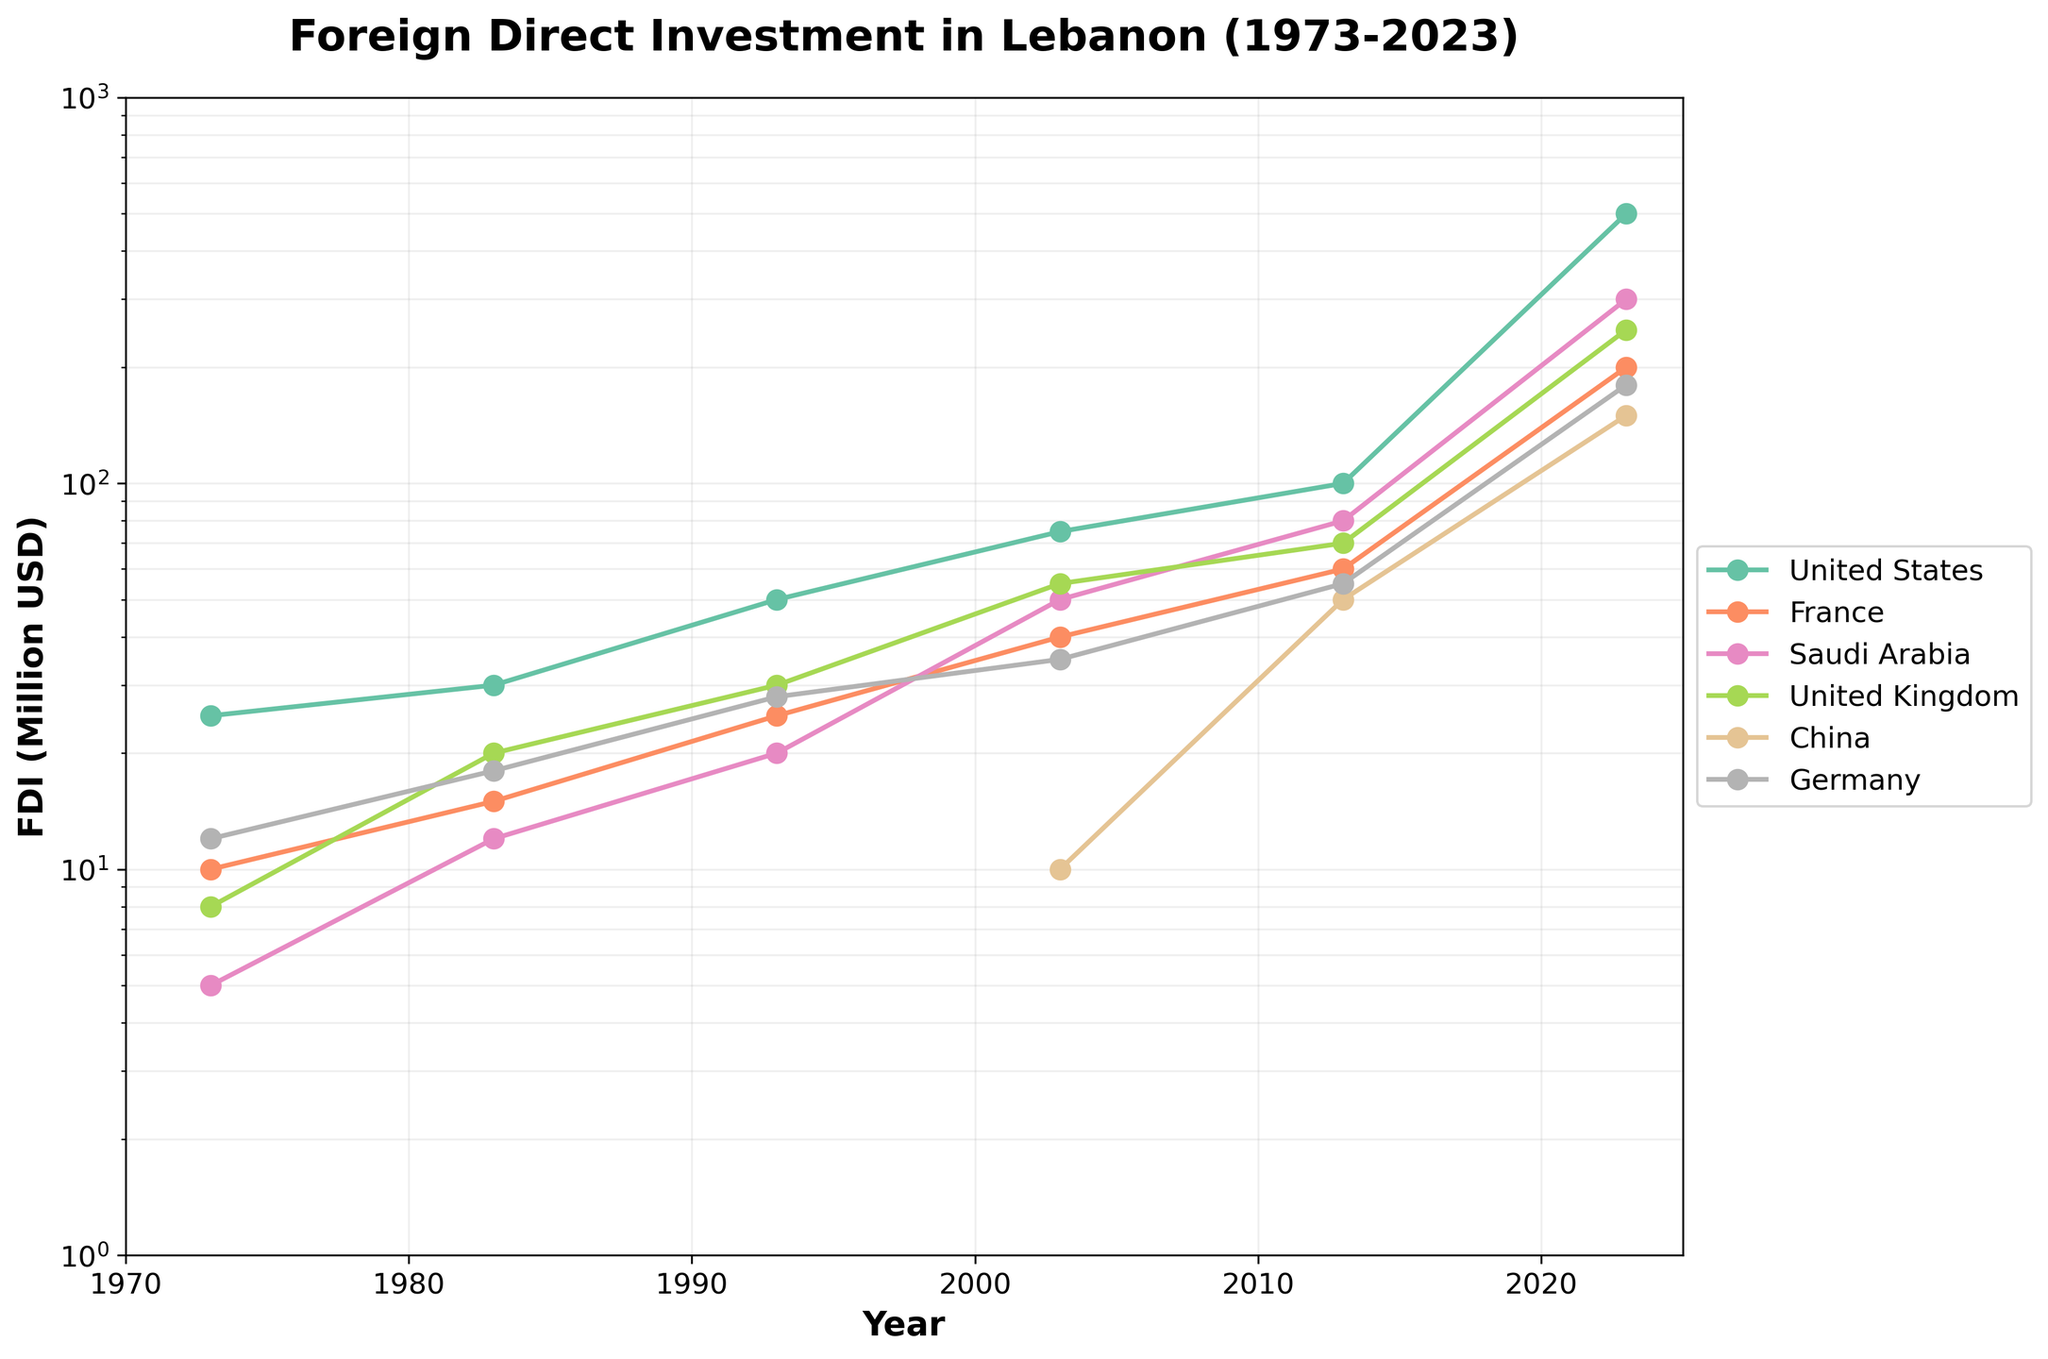What's the title of the plot? Look at the top of the chart. The title of the plot is usually written in a larger, bold font.
Answer: Foreign Direct Investment in Lebanon (1973-2023) Which country shows the highest FDI in 2023? Observe the data points on the plot for the year 2023. Identify which data point is the highest and note the corresponding country.
Answer: United States How many countries are represented in the plot? Count the number of unique lines on the plot, as each line corresponds to a different country.
Answer: 6 What's the general trend of FDI from China between 2003 and 2023? Observe the line representing China from 2003 to 2023. Determine if it is increasing, decreasing, or remaining constant.
Answer: Increasing Which country had a higher FDI in 1993, Saudi Arabia or Germany? Compare the values of the data points for Saudi Arabia and Germany in the year 1993.
Answer: Germany What is the approximate FDI value of France in 2013? Locate the data point for France in the year 2013 and read off the value from the y-axis.
Answer: 60 million USD Between which years did the United Kingdom see the most significant increase in FDI? Observe the slope of the line representing the United Kingdom. Identify the period with the steepest slope, indicating the most significant increase.
Answer: 2003 to 2013 How does the FDI from the United States in 1973 compare to that in 2023? Compare the heights of the data points for the United States in 1973 and 2023.
Answer: FDI in 2023 is much higher What's the overall trend of FDI from Saudi Arabia throughout the 50-year period? Look at the progression of the line representing Saudi Arabia from 1973 to 2023. Observe if it generally goes upward, downward, or remains flat.
Answer: Increasing Which country had the lowest FDI in 1983, and what was the approximate value? Compare the FDI values of all countries in the year 1983. Identify the smallest value and the corresponding country.
Answer: Saudi Arabia, 12 million USD 